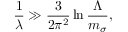<formula> <loc_0><loc_0><loc_500><loc_500>\frac { 1 } { \lambda } \gg \frac { 3 } { 2 \pi ^ { 2 } } \ln { \frac { \Lambda } { m _ { \sigma } } } ,</formula> 